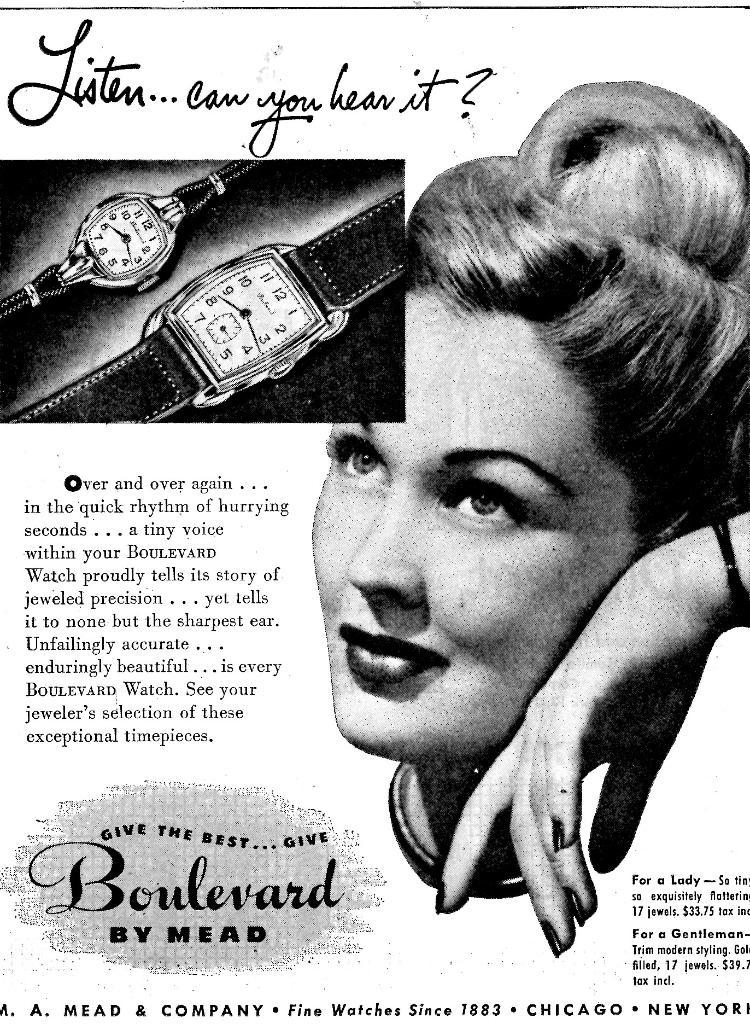<image>
Describe the image concisely. A poster advertisement in black and white with a woman featured leaning on her hand and the phrase "Listen, can you hear it?" above a picture of two watches 